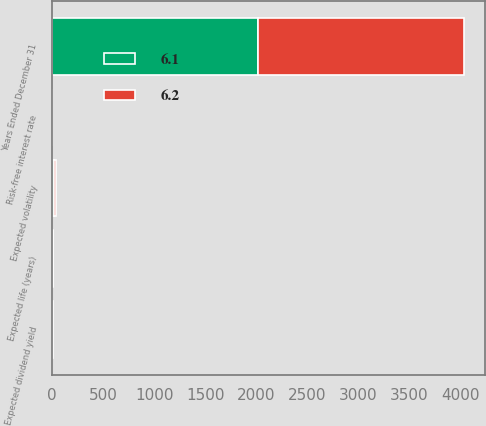<chart> <loc_0><loc_0><loc_500><loc_500><stacked_bar_chart><ecel><fcel>Years Ended December 31<fcel>Expected dividend yield<fcel>Risk-free interest rate<fcel>Expected volatility<fcel>Expected life (years)<nl><fcel>6.2<fcel>2018<fcel>3.4<fcel>2.9<fcel>19.1<fcel>6.1<nl><fcel>6.1<fcel>2016<fcel>3.8<fcel>1.4<fcel>19.6<fcel>6.2<nl></chart> 